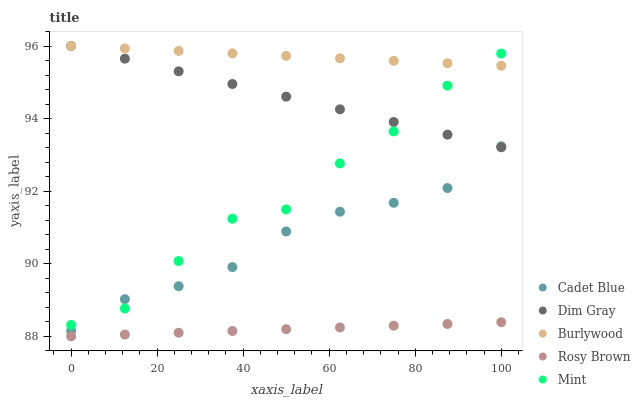Does Rosy Brown have the minimum area under the curve?
Answer yes or no. Yes. Does Burlywood have the maximum area under the curve?
Answer yes or no. Yes. Does Dim Gray have the minimum area under the curve?
Answer yes or no. No. Does Dim Gray have the maximum area under the curve?
Answer yes or no. No. Is Rosy Brown the smoothest?
Answer yes or no. Yes. Is Mint the roughest?
Answer yes or no. Yes. Is Dim Gray the smoothest?
Answer yes or no. No. Is Dim Gray the roughest?
Answer yes or no. No. Does Rosy Brown have the lowest value?
Answer yes or no. Yes. Does Dim Gray have the lowest value?
Answer yes or no. No. Does Dim Gray have the highest value?
Answer yes or no. Yes. Does Cadet Blue have the highest value?
Answer yes or no. No. Is Rosy Brown less than Mint?
Answer yes or no. Yes. Is Burlywood greater than Rosy Brown?
Answer yes or no. Yes. Does Burlywood intersect Mint?
Answer yes or no. Yes. Is Burlywood less than Mint?
Answer yes or no. No. Is Burlywood greater than Mint?
Answer yes or no. No. Does Rosy Brown intersect Mint?
Answer yes or no. No. 